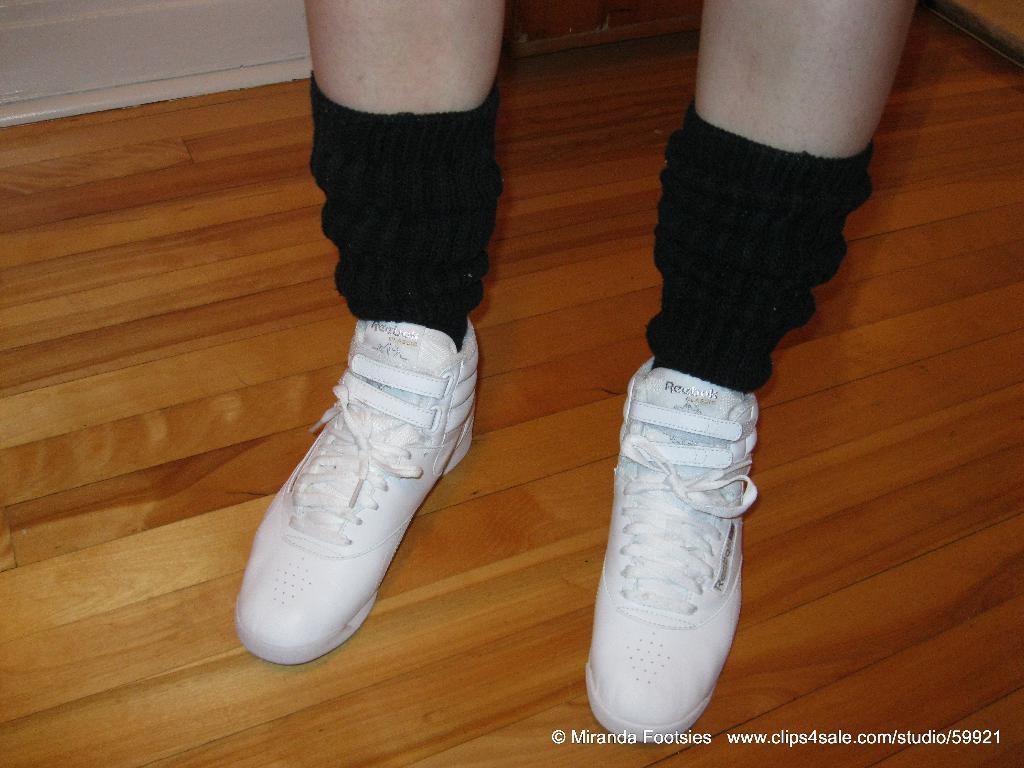Can you describe this image briefly? In this image I can see legs of a person and I can see this person is wearing black colour socks and white shoes. I can also see a watermark on the bottom right side of the image. 